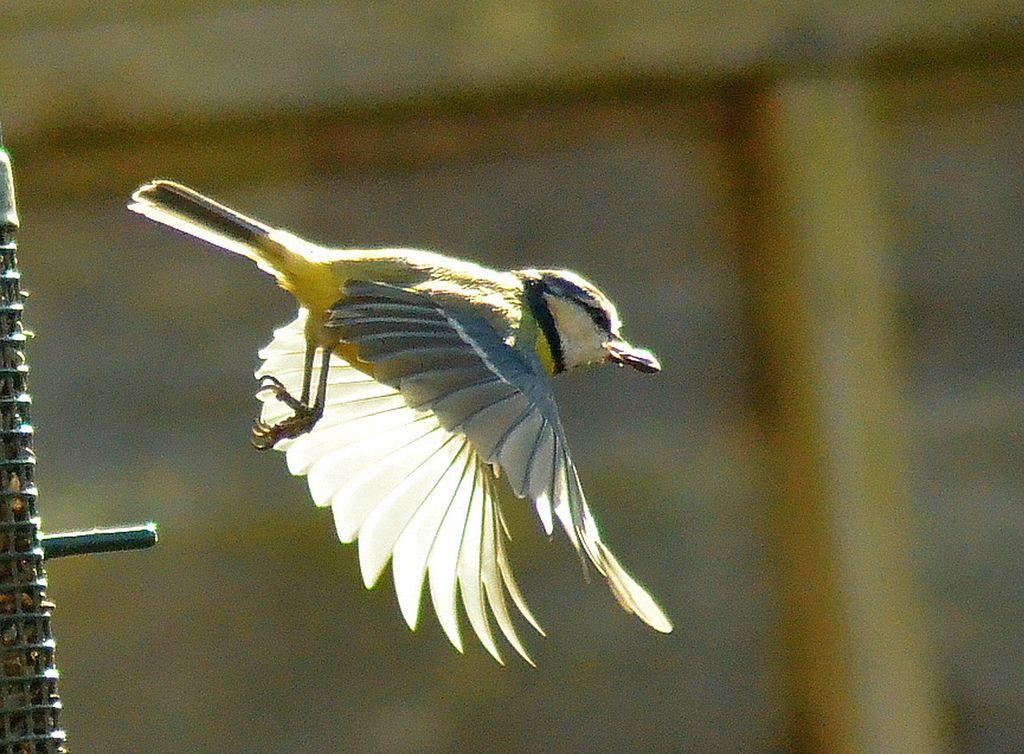What is the main subject of the image? There is a bird in the image. What is the bird doing in the image? The bird is flying. Can you describe the background of the image? The background of the image is blurred. What type of trousers is the bird wearing in the image? Birds do not wear trousers, so this question cannot be answered. 